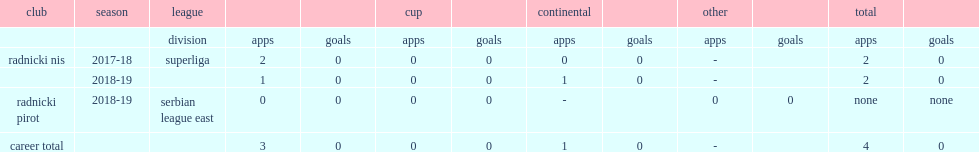Which league did petar cirkovic make a debut for radnicki nis in the 2017-18 season? Superliga. 